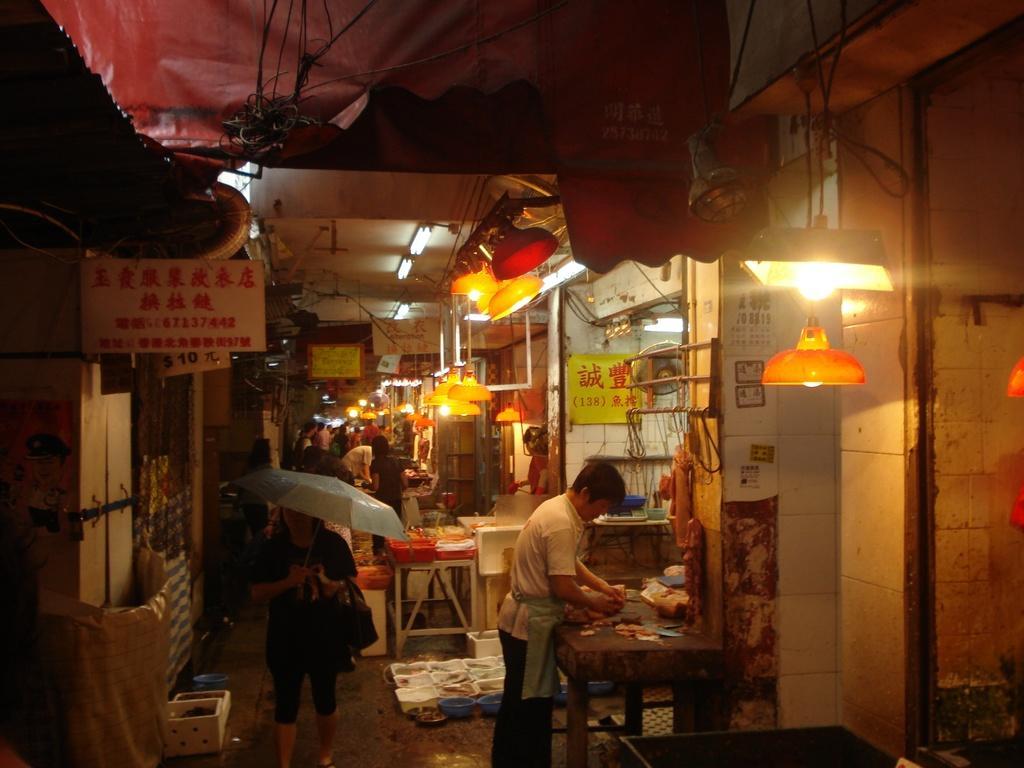Can you describe this image briefly? This picture is clicked in the market where the group of persons are standing and walking. In the front the person is holding umbrella and walking. At the right side the person is standing and doing work. There are lights hanging and there are some sign boards. In the background there are person standing and walking. At the right side there are tiles. 